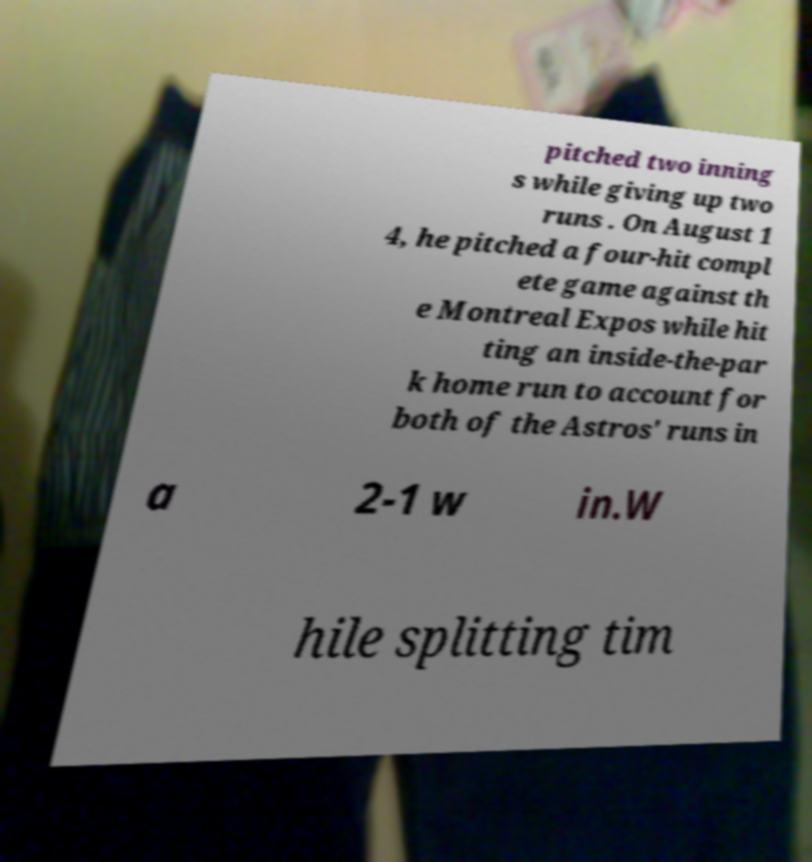There's text embedded in this image that I need extracted. Can you transcribe it verbatim? pitched two inning s while giving up two runs . On August 1 4, he pitched a four-hit compl ete game against th e Montreal Expos while hit ting an inside-the-par k home run to account for both of the Astros' runs in a 2-1 w in.W hile splitting tim 